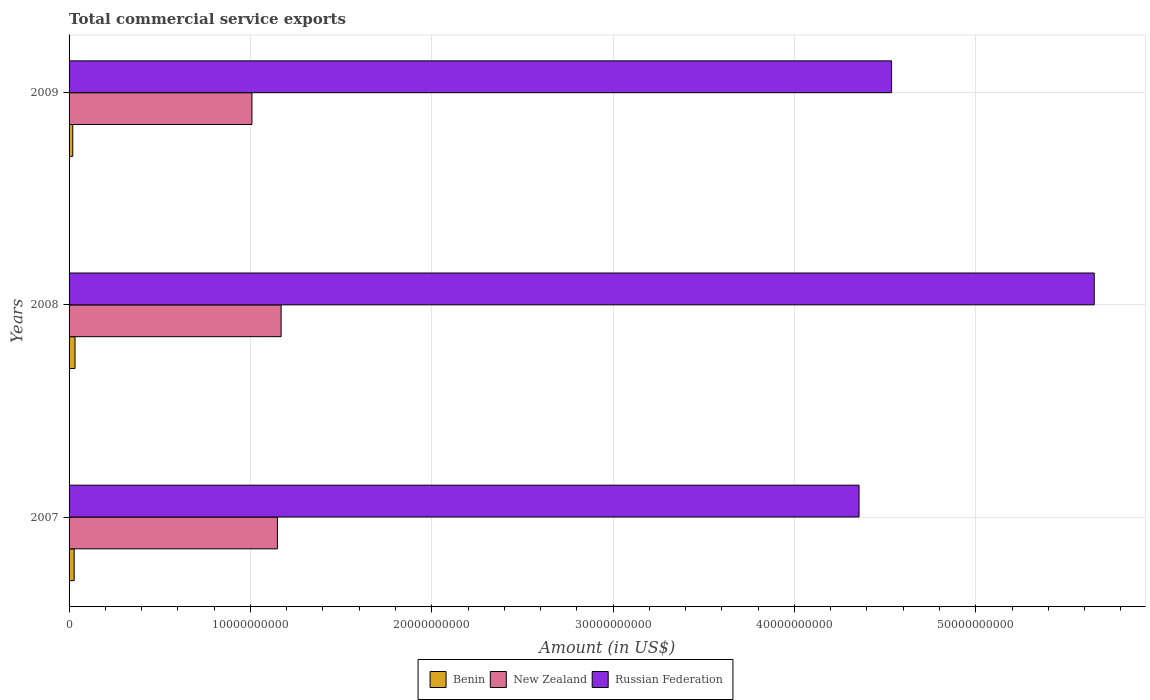How many different coloured bars are there?
Make the answer very short. 3. How many bars are there on the 1st tick from the top?
Your answer should be very brief. 3. What is the label of the 1st group of bars from the top?
Your answer should be very brief. 2009. In how many cases, is the number of bars for a given year not equal to the number of legend labels?
Give a very brief answer. 0. What is the total commercial service exports in Russian Federation in 2008?
Ensure brevity in your answer.  5.65e+1. Across all years, what is the maximum total commercial service exports in New Zealand?
Offer a terse response. 1.17e+1. Across all years, what is the minimum total commercial service exports in Russian Federation?
Ensure brevity in your answer.  4.36e+1. In which year was the total commercial service exports in Benin maximum?
Your response must be concise. 2008. In which year was the total commercial service exports in Russian Federation minimum?
Your answer should be very brief. 2007. What is the total total commercial service exports in Russian Federation in the graph?
Make the answer very short. 1.45e+11. What is the difference between the total commercial service exports in Benin in 2007 and that in 2008?
Provide a short and direct response. -4.74e+07. What is the difference between the total commercial service exports in Benin in 2008 and the total commercial service exports in New Zealand in 2007?
Your answer should be very brief. -1.12e+1. What is the average total commercial service exports in Russian Federation per year?
Provide a short and direct response. 4.85e+1. In the year 2008, what is the difference between the total commercial service exports in New Zealand and total commercial service exports in Russian Federation?
Your answer should be very brief. -4.48e+1. What is the ratio of the total commercial service exports in New Zealand in 2008 to that in 2009?
Keep it short and to the point. 1.16. Is the difference between the total commercial service exports in New Zealand in 2008 and 2009 greater than the difference between the total commercial service exports in Russian Federation in 2008 and 2009?
Keep it short and to the point. No. What is the difference between the highest and the second highest total commercial service exports in New Zealand?
Provide a succinct answer. 2.03e+08. What is the difference between the highest and the lowest total commercial service exports in New Zealand?
Offer a very short reply. 1.61e+09. In how many years, is the total commercial service exports in Benin greater than the average total commercial service exports in Benin taken over all years?
Keep it short and to the point. 2. What does the 2nd bar from the top in 2008 represents?
Your answer should be very brief. New Zealand. What does the 2nd bar from the bottom in 2009 represents?
Your answer should be very brief. New Zealand. How many bars are there?
Offer a terse response. 9. Are all the bars in the graph horizontal?
Your response must be concise. Yes. How many years are there in the graph?
Offer a terse response. 3. Are the values on the major ticks of X-axis written in scientific E-notation?
Give a very brief answer. No. Does the graph contain any zero values?
Provide a short and direct response. No. Where does the legend appear in the graph?
Provide a succinct answer. Bottom center. What is the title of the graph?
Give a very brief answer. Total commercial service exports. What is the label or title of the Y-axis?
Ensure brevity in your answer.  Years. What is the Amount (in US$) in Benin in 2007?
Your answer should be compact. 2.81e+08. What is the Amount (in US$) in New Zealand in 2007?
Provide a succinct answer. 1.15e+1. What is the Amount (in US$) in Russian Federation in 2007?
Offer a terse response. 4.36e+1. What is the Amount (in US$) in Benin in 2008?
Provide a succinct answer. 3.28e+08. What is the Amount (in US$) in New Zealand in 2008?
Provide a short and direct response. 1.17e+1. What is the Amount (in US$) of Russian Federation in 2008?
Make the answer very short. 5.65e+1. What is the Amount (in US$) of Benin in 2009?
Ensure brevity in your answer.  2.04e+08. What is the Amount (in US$) in New Zealand in 2009?
Offer a terse response. 1.01e+1. What is the Amount (in US$) of Russian Federation in 2009?
Your response must be concise. 4.54e+1. Across all years, what is the maximum Amount (in US$) of Benin?
Give a very brief answer. 3.28e+08. Across all years, what is the maximum Amount (in US$) of New Zealand?
Offer a very short reply. 1.17e+1. Across all years, what is the maximum Amount (in US$) of Russian Federation?
Your answer should be very brief. 5.65e+1. Across all years, what is the minimum Amount (in US$) in Benin?
Give a very brief answer. 2.04e+08. Across all years, what is the minimum Amount (in US$) in New Zealand?
Offer a very short reply. 1.01e+1. Across all years, what is the minimum Amount (in US$) of Russian Federation?
Offer a very short reply. 4.36e+1. What is the total Amount (in US$) of Benin in the graph?
Ensure brevity in your answer.  8.13e+08. What is the total Amount (in US$) of New Zealand in the graph?
Your response must be concise. 3.33e+1. What is the total Amount (in US$) of Russian Federation in the graph?
Make the answer very short. 1.45e+11. What is the difference between the Amount (in US$) in Benin in 2007 and that in 2008?
Provide a succinct answer. -4.74e+07. What is the difference between the Amount (in US$) in New Zealand in 2007 and that in 2008?
Your answer should be very brief. -2.03e+08. What is the difference between the Amount (in US$) of Russian Federation in 2007 and that in 2008?
Provide a succinct answer. -1.30e+1. What is the difference between the Amount (in US$) in Benin in 2007 and that in 2009?
Ensure brevity in your answer.  7.74e+07. What is the difference between the Amount (in US$) in New Zealand in 2007 and that in 2009?
Your answer should be very brief. 1.41e+09. What is the difference between the Amount (in US$) of Russian Federation in 2007 and that in 2009?
Keep it short and to the point. -1.79e+09. What is the difference between the Amount (in US$) of Benin in 2008 and that in 2009?
Provide a short and direct response. 1.25e+08. What is the difference between the Amount (in US$) of New Zealand in 2008 and that in 2009?
Provide a short and direct response. 1.61e+09. What is the difference between the Amount (in US$) in Russian Federation in 2008 and that in 2009?
Keep it short and to the point. 1.12e+1. What is the difference between the Amount (in US$) in Benin in 2007 and the Amount (in US$) in New Zealand in 2008?
Provide a succinct answer. -1.14e+1. What is the difference between the Amount (in US$) of Benin in 2007 and the Amount (in US$) of Russian Federation in 2008?
Ensure brevity in your answer.  -5.63e+1. What is the difference between the Amount (in US$) in New Zealand in 2007 and the Amount (in US$) in Russian Federation in 2008?
Your response must be concise. -4.50e+1. What is the difference between the Amount (in US$) of Benin in 2007 and the Amount (in US$) of New Zealand in 2009?
Ensure brevity in your answer.  -9.80e+09. What is the difference between the Amount (in US$) of Benin in 2007 and the Amount (in US$) of Russian Federation in 2009?
Your response must be concise. -4.51e+1. What is the difference between the Amount (in US$) in New Zealand in 2007 and the Amount (in US$) in Russian Federation in 2009?
Make the answer very short. -3.39e+1. What is the difference between the Amount (in US$) in Benin in 2008 and the Amount (in US$) in New Zealand in 2009?
Offer a very short reply. -9.76e+09. What is the difference between the Amount (in US$) of Benin in 2008 and the Amount (in US$) of Russian Federation in 2009?
Offer a very short reply. -4.50e+1. What is the difference between the Amount (in US$) of New Zealand in 2008 and the Amount (in US$) of Russian Federation in 2009?
Give a very brief answer. -3.37e+1. What is the average Amount (in US$) of Benin per year?
Ensure brevity in your answer.  2.71e+08. What is the average Amount (in US$) in New Zealand per year?
Make the answer very short. 1.11e+1. What is the average Amount (in US$) of Russian Federation per year?
Give a very brief answer. 4.85e+1. In the year 2007, what is the difference between the Amount (in US$) of Benin and Amount (in US$) of New Zealand?
Keep it short and to the point. -1.12e+1. In the year 2007, what is the difference between the Amount (in US$) in Benin and Amount (in US$) in Russian Federation?
Provide a short and direct response. -4.33e+1. In the year 2007, what is the difference between the Amount (in US$) in New Zealand and Amount (in US$) in Russian Federation?
Your response must be concise. -3.21e+1. In the year 2008, what is the difference between the Amount (in US$) in Benin and Amount (in US$) in New Zealand?
Offer a terse response. -1.14e+1. In the year 2008, what is the difference between the Amount (in US$) in Benin and Amount (in US$) in Russian Federation?
Ensure brevity in your answer.  -5.62e+1. In the year 2008, what is the difference between the Amount (in US$) in New Zealand and Amount (in US$) in Russian Federation?
Ensure brevity in your answer.  -4.48e+1. In the year 2009, what is the difference between the Amount (in US$) in Benin and Amount (in US$) in New Zealand?
Your answer should be compact. -9.88e+09. In the year 2009, what is the difference between the Amount (in US$) in Benin and Amount (in US$) in Russian Federation?
Offer a terse response. -4.52e+1. In the year 2009, what is the difference between the Amount (in US$) of New Zealand and Amount (in US$) of Russian Federation?
Provide a short and direct response. -3.53e+1. What is the ratio of the Amount (in US$) in Benin in 2007 to that in 2008?
Your answer should be compact. 0.86. What is the ratio of the Amount (in US$) of New Zealand in 2007 to that in 2008?
Provide a succinct answer. 0.98. What is the ratio of the Amount (in US$) of Russian Federation in 2007 to that in 2008?
Ensure brevity in your answer.  0.77. What is the ratio of the Amount (in US$) in Benin in 2007 to that in 2009?
Ensure brevity in your answer.  1.38. What is the ratio of the Amount (in US$) in New Zealand in 2007 to that in 2009?
Ensure brevity in your answer.  1.14. What is the ratio of the Amount (in US$) in Russian Federation in 2007 to that in 2009?
Keep it short and to the point. 0.96. What is the ratio of the Amount (in US$) of Benin in 2008 to that in 2009?
Your answer should be very brief. 1.61. What is the ratio of the Amount (in US$) in New Zealand in 2008 to that in 2009?
Your response must be concise. 1.16. What is the ratio of the Amount (in US$) of Russian Federation in 2008 to that in 2009?
Provide a short and direct response. 1.25. What is the difference between the highest and the second highest Amount (in US$) of Benin?
Provide a short and direct response. 4.74e+07. What is the difference between the highest and the second highest Amount (in US$) of New Zealand?
Your answer should be very brief. 2.03e+08. What is the difference between the highest and the second highest Amount (in US$) in Russian Federation?
Give a very brief answer. 1.12e+1. What is the difference between the highest and the lowest Amount (in US$) in Benin?
Give a very brief answer. 1.25e+08. What is the difference between the highest and the lowest Amount (in US$) of New Zealand?
Your response must be concise. 1.61e+09. What is the difference between the highest and the lowest Amount (in US$) of Russian Federation?
Offer a very short reply. 1.30e+1. 